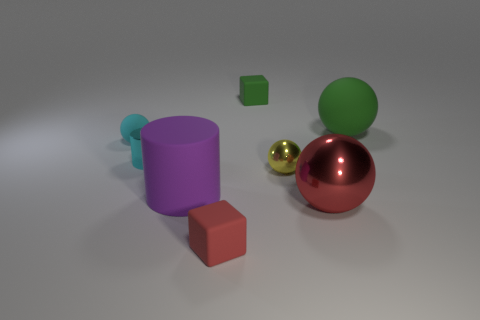Does the large shiny ball have the same color as the small matte block that is in front of the cyan metal object?
Give a very brief answer. Yes. Is the number of tiny rubber objects that are behind the large green rubber ball greater than the number of small cyan metallic cylinders?
Keep it short and to the point. No. Is the shape of the purple object the same as the tiny shiny thing that is to the left of the red matte thing?
Your answer should be compact. Yes. There is a green matte object that is the same shape as the tiny red rubber thing; what size is it?
Your response must be concise. Small. Is the number of objects greater than the number of red objects?
Ensure brevity in your answer.  Yes. Do the cyan matte object and the large purple object have the same shape?
Your response must be concise. No. The small sphere to the right of the block that is in front of the tiny cyan sphere is made of what material?
Offer a very short reply. Metal. There is a tiny sphere that is the same color as the small shiny cylinder; what is its material?
Keep it short and to the point. Rubber. Do the yellow metal thing and the purple matte cylinder have the same size?
Your response must be concise. No. Are there any large red shiny things to the left of the tiny sphere that is to the right of the matte cylinder?
Ensure brevity in your answer.  No. 